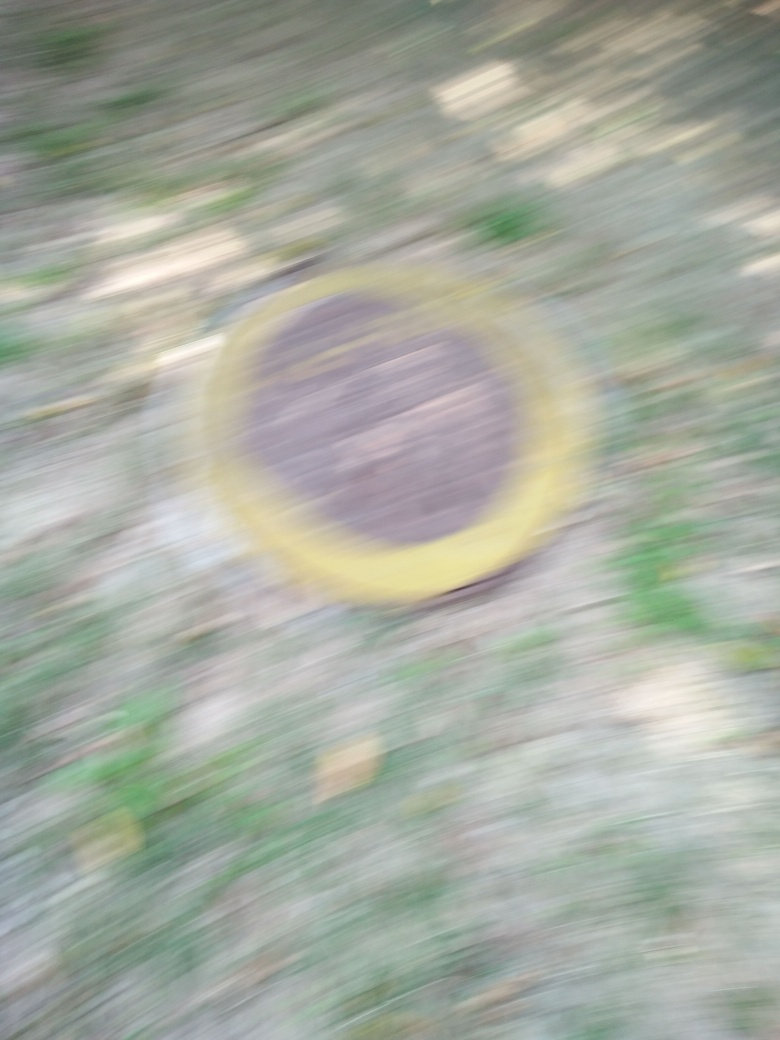What could have caused this blurry image? The blurry effect in this image could be due to several factors, such as a quick movement of the camera or the subject during the capture, a long exposure time without a stable support for the camera, or an accidental movement as the photo was being taken. 